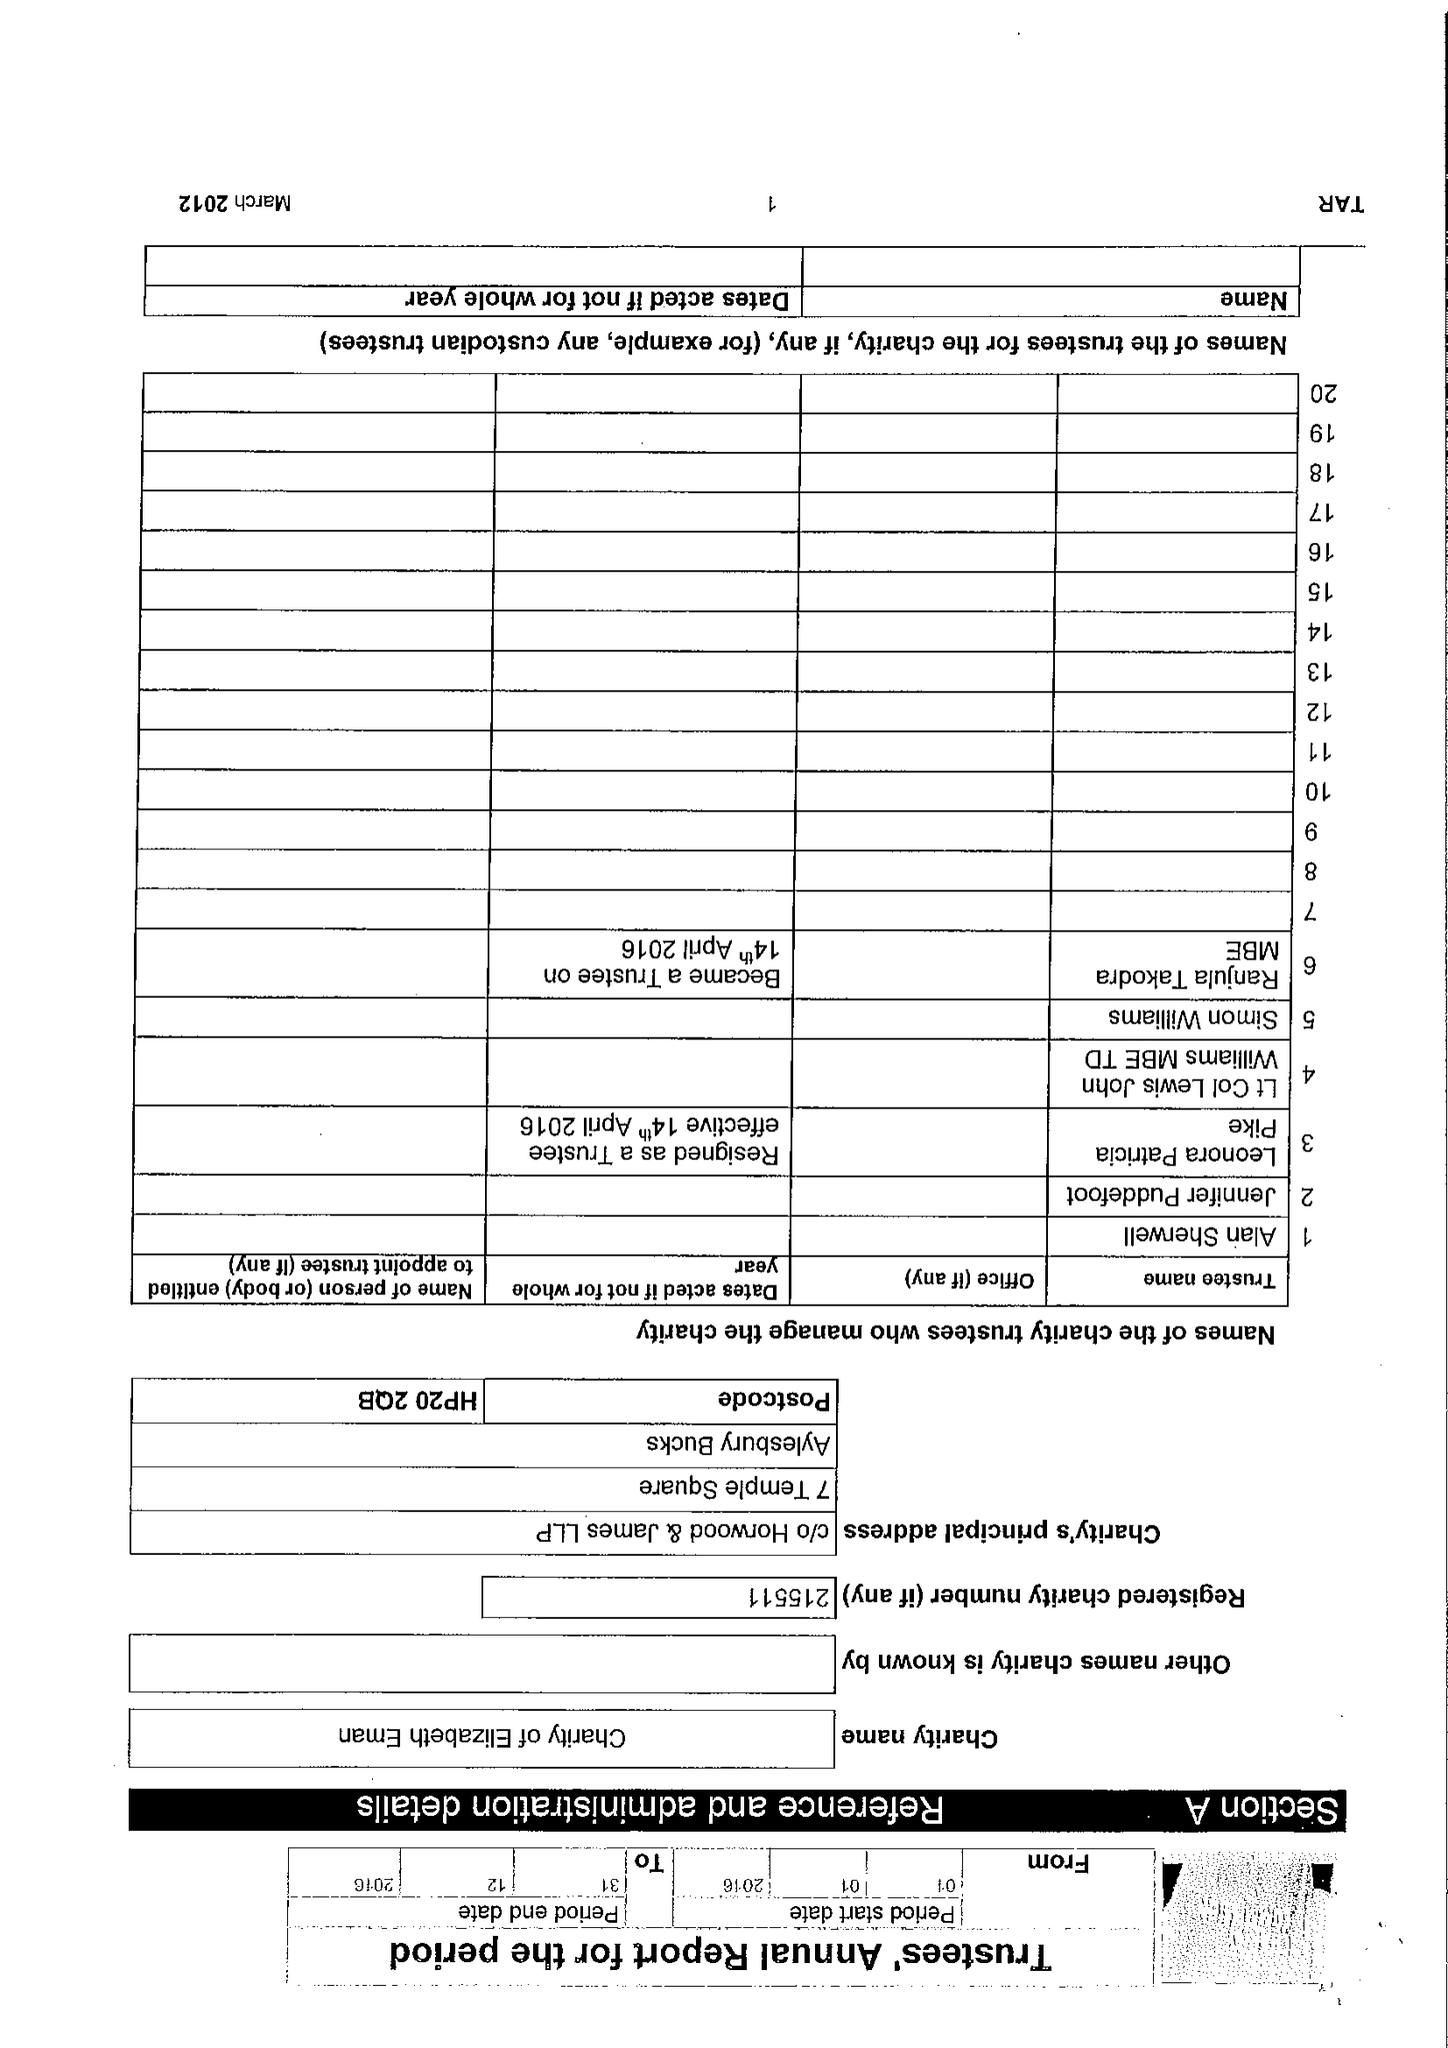What is the value for the address__street_line?
Answer the question using a single word or phrase. 7 TEMPLE SQUARE 